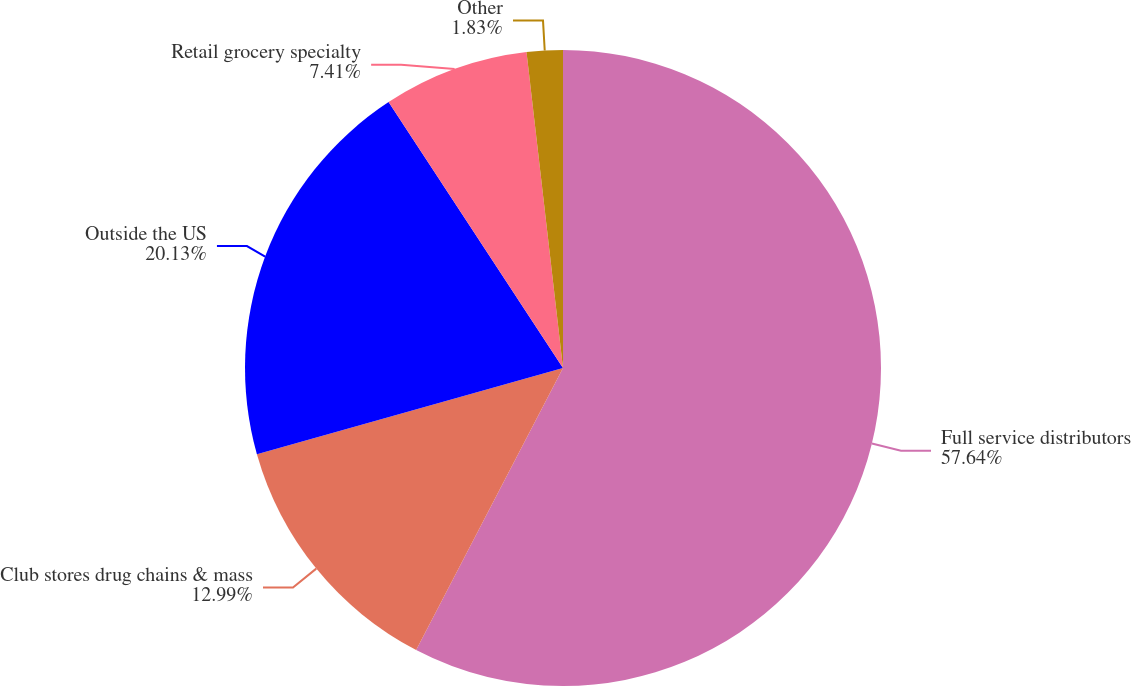Convert chart. <chart><loc_0><loc_0><loc_500><loc_500><pie_chart><fcel>Full service distributors<fcel>Club stores drug chains & mass<fcel>Outside the US<fcel>Retail grocery specialty<fcel>Other<nl><fcel>57.64%<fcel>12.99%<fcel>20.13%<fcel>7.41%<fcel>1.83%<nl></chart> 